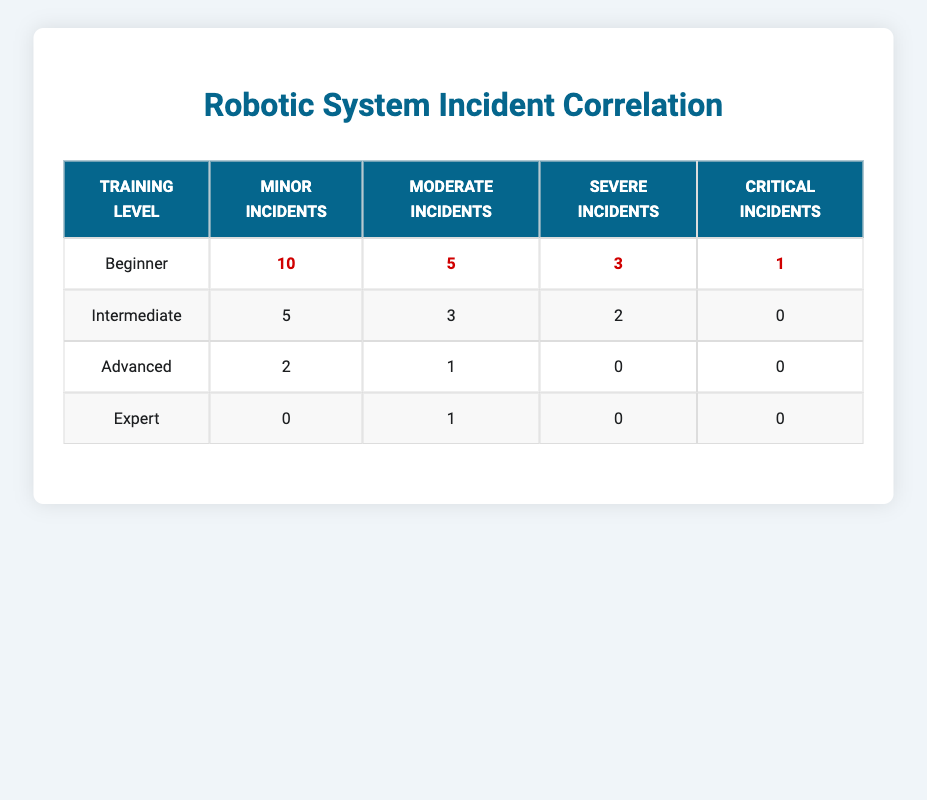What is the number of minor incidents reported for operators at the Beginner training level? The total number of minor incidents reported for operators at the Beginner level is 10, which can be directly retrieved from the table.
Answer: 10 How many moderate incidents are reported for operators with Intermediate training? The table indicates that there were 3 moderate incidents for operators at the Intermediate training level, which can be found directly in the respective row.
Answer: 3 What is the total number of incidents (minor, moderate, severe, and critical) reported by those at the Advanced training level? To find the total incidents for the Advanced level, we sum the incidents: 2 (minor) + 1 (moderate) + 0 (severe) + 0 (critical) = 3. Therefore, the total number of incidents is 3.
Answer: 3 Are there more severe incidents reported by the Beginner trainees than by the Intermediate trainees? For Beginner trainees, there are 3 severe incidents, and for Intermediate, there are 2 severe incidents. Since 3 is greater than 2, the statement is true.
Answer: Yes What is the difference in the number of minor incidents between operators at the Beginner and Expert training levels? The Beginner level has 10 minor incidents, while the Expert level has 0. The difference is calculated as 10 - 0 = 10.
Answer: 10 How many total critical incidents were reported across all training levels? Summing the critical incidents from all levels gives us: 1 (Beginner) + 0 (Intermediate) + 0 (Advanced) + 0 (Expert) = 1. Thus, the total number of critical incidents is 1.
Answer: 1 What is the average number of moderate incidents per training level? To find the average, we sum the moderate incidents: 5 (Beginner) + 3 (Intermediate) + 1 (Advanced) + 1 (Expert) = 10. There are 4 levels, so the average is 10 / 4 = 2.5.
Answer: 2.5 Is there a training level that reported no minor incidents at all? By examining the table, we see that only the Expert level reported 0 minor incidents, making the answer true for this statement.
Answer: Yes What is the ratio of minor incidents reported at the Beginner level compared to the Expert level? The Beginner level reported 10 minor incidents, while the Expert level reported 0. The ratio is 10:0, which can be said as undefined but represents that Beginners reported significantly more.
Answer: Undefined (or representative of a very high ratio) 